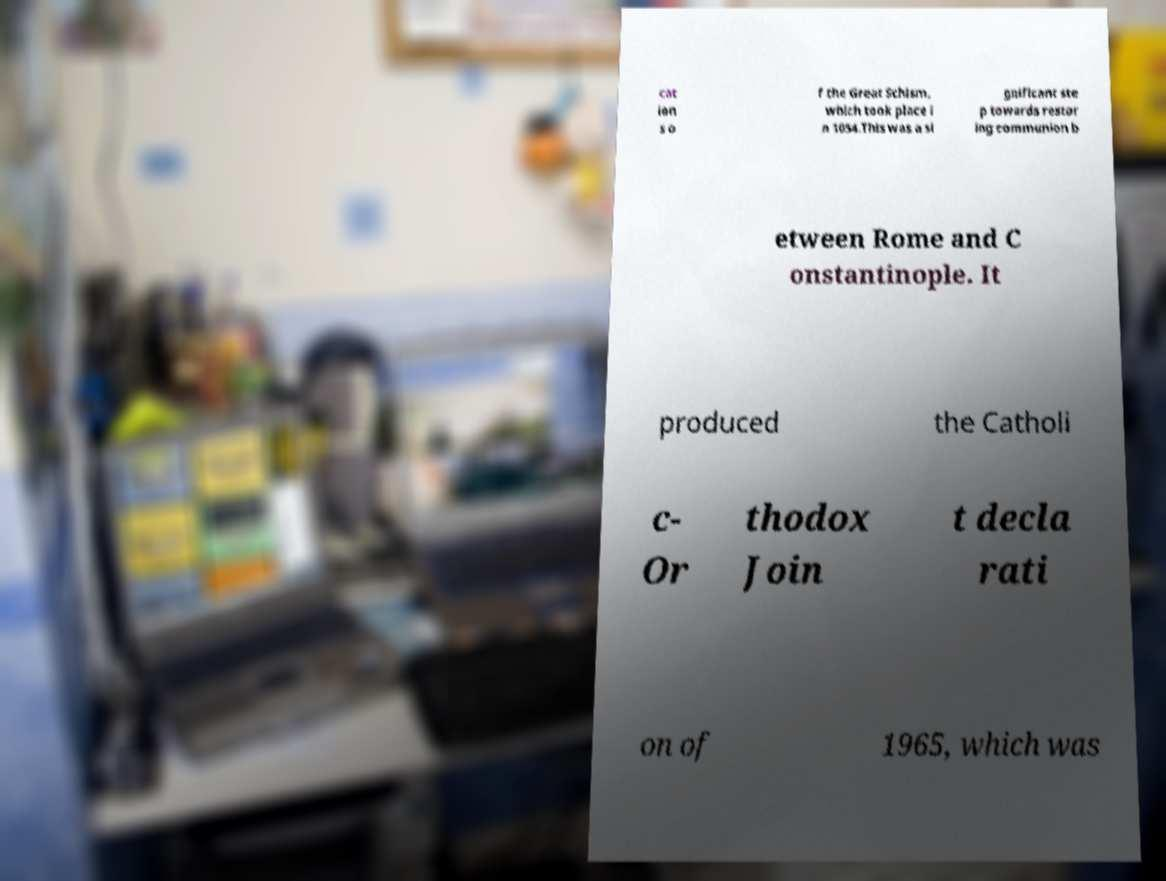There's text embedded in this image that I need extracted. Can you transcribe it verbatim? cat ion s o f the Great Schism, which took place i n 1054.This was a si gnificant ste p towards restor ing communion b etween Rome and C onstantinople. It produced the Catholi c- Or thodox Join t decla rati on of 1965, which was 